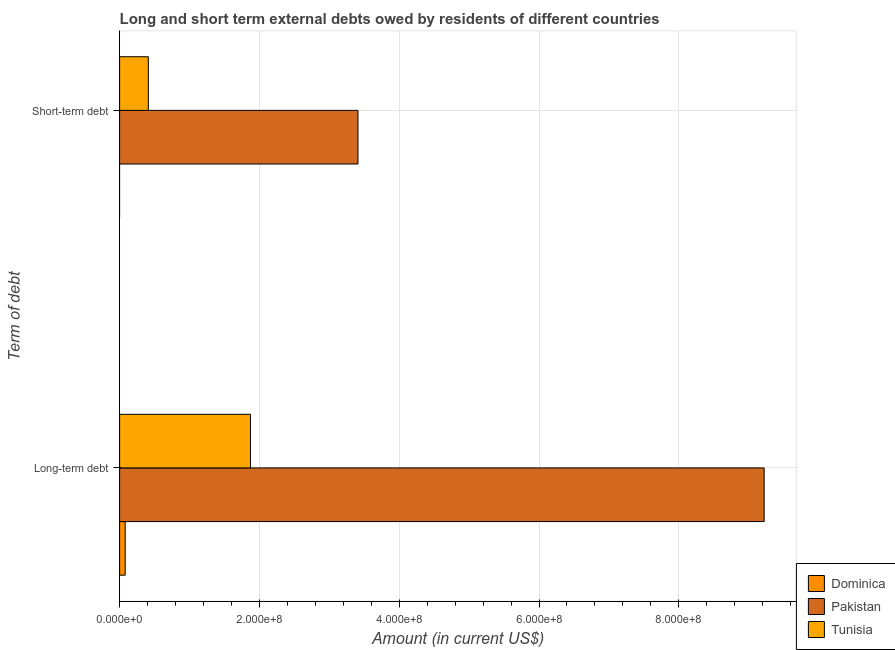How many different coloured bars are there?
Ensure brevity in your answer.  3. How many groups of bars are there?
Your response must be concise. 2. Are the number of bars per tick equal to the number of legend labels?
Your answer should be very brief. No. How many bars are there on the 2nd tick from the top?
Provide a short and direct response. 3. How many bars are there on the 2nd tick from the bottom?
Your answer should be compact. 2. What is the label of the 2nd group of bars from the top?
Keep it short and to the point. Long-term debt. What is the long-term debts owed by residents in Dominica?
Your answer should be compact. 7.98e+06. Across all countries, what is the maximum long-term debts owed by residents?
Ensure brevity in your answer.  9.22e+08. In which country was the short-term debts owed by residents maximum?
Ensure brevity in your answer.  Pakistan. What is the total long-term debts owed by residents in the graph?
Your answer should be very brief. 1.12e+09. What is the difference between the long-term debts owed by residents in Dominica and that in Pakistan?
Give a very brief answer. -9.14e+08. What is the difference between the long-term debts owed by residents in Dominica and the short-term debts owed by residents in Tunisia?
Provide a short and direct response. -3.31e+07. What is the average short-term debts owed by residents per country?
Your answer should be very brief. 1.27e+08. What is the difference between the short-term debts owed by residents and long-term debts owed by residents in Tunisia?
Offer a very short reply. -1.46e+08. In how many countries, is the short-term debts owed by residents greater than 520000000 US$?
Keep it short and to the point. 0. What is the ratio of the long-term debts owed by residents in Pakistan to that in Tunisia?
Give a very brief answer. 4.92. Is the long-term debts owed by residents in Pakistan less than that in Dominica?
Keep it short and to the point. No. In how many countries, is the short-term debts owed by residents greater than the average short-term debts owed by residents taken over all countries?
Ensure brevity in your answer.  1. What is the difference between two consecutive major ticks on the X-axis?
Give a very brief answer. 2.00e+08. Are the values on the major ticks of X-axis written in scientific E-notation?
Your answer should be compact. Yes. Does the graph contain grids?
Keep it short and to the point. Yes. Where does the legend appear in the graph?
Your answer should be compact. Bottom right. How are the legend labels stacked?
Your answer should be compact. Vertical. What is the title of the graph?
Make the answer very short. Long and short term external debts owed by residents of different countries. Does "Channel Islands" appear as one of the legend labels in the graph?
Offer a very short reply. No. What is the label or title of the X-axis?
Make the answer very short. Amount (in current US$). What is the label or title of the Y-axis?
Make the answer very short. Term of debt. What is the Amount (in current US$) in Dominica in Long-term debt?
Keep it short and to the point. 7.98e+06. What is the Amount (in current US$) of Pakistan in Long-term debt?
Give a very brief answer. 9.22e+08. What is the Amount (in current US$) of Tunisia in Long-term debt?
Offer a terse response. 1.87e+08. What is the Amount (in current US$) of Pakistan in Short-term debt?
Ensure brevity in your answer.  3.41e+08. What is the Amount (in current US$) in Tunisia in Short-term debt?
Offer a very short reply. 4.11e+07. Across all Term of debt, what is the maximum Amount (in current US$) of Dominica?
Your answer should be very brief. 7.98e+06. Across all Term of debt, what is the maximum Amount (in current US$) of Pakistan?
Your answer should be compact. 9.22e+08. Across all Term of debt, what is the maximum Amount (in current US$) in Tunisia?
Give a very brief answer. 1.87e+08. Across all Term of debt, what is the minimum Amount (in current US$) in Dominica?
Offer a terse response. 0. Across all Term of debt, what is the minimum Amount (in current US$) in Pakistan?
Your response must be concise. 3.41e+08. Across all Term of debt, what is the minimum Amount (in current US$) in Tunisia?
Your answer should be compact. 4.11e+07. What is the total Amount (in current US$) in Dominica in the graph?
Your answer should be compact. 7.98e+06. What is the total Amount (in current US$) in Pakistan in the graph?
Ensure brevity in your answer.  1.26e+09. What is the total Amount (in current US$) in Tunisia in the graph?
Your response must be concise. 2.28e+08. What is the difference between the Amount (in current US$) in Pakistan in Long-term debt and that in Short-term debt?
Offer a very short reply. 5.81e+08. What is the difference between the Amount (in current US$) in Tunisia in Long-term debt and that in Short-term debt?
Ensure brevity in your answer.  1.46e+08. What is the difference between the Amount (in current US$) in Dominica in Long-term debt and the Amount (in current US$) in Pakistan in Short-term debt?
Provide a short and direct response. -3.33e+08. What is the difference between the Amount (in current US$) in Dominica in Long-term debt and the Amount (in current US$) in Tunisia in Short-term debt?
Keep it short and to the point. -3.31e+07. What is the difference between the Amount (in current US$) in Pakistan in Long-term debt and the Amount (in current US$) in Tunisia in Short-term debt?
Make the answer very short. 8.81e+08. What is the average Amount (in current US$) in Dominica per Term of debt?
Offer a terse response. 3.99e+06. What is the average Amount (in current US$) of Pakistan per Term of debt?
Offer a terse response. 6.32e+08. What is the average Amount (in current US$) in Tunisia per Term of debt?
Give a very brief answer. 1.14e+08. What is the difference between the Amount (in current US$) of Dominica and Amount (in current US$) of Pakistan in Long-term debt?
Offer a terse response. -9.14e+08. What is the difference between the Amount (in current US$) in Dominica and Amount (in current US$) in Tunisia in Long-term debt?
Offer a terse response. -1.79e+08. What is the difference between the Amount (in current US$) in Pakistan and Amount (in current US$) in Tunisia in Long-term debt?
Ensure brevity in your answer.  7.35e+08. What is the difference between the Amount (in current US$) of Pakistan and Amount (in current US$) of Tunisia in Short-term debt?
Give a very brief answer. 3.00e+08. What is the ratio of the Amount (in current US$) in Pakistan in Long-term debt to that in Short-term debt?
Keep it short and to the point. 2.7. What is the ratio of the Amount (in current US$) in Tunisia in Long-term debt to that in Short-term debt?
Give a very brief answer. 4.56. What is the difference between the highest and the second highest Amount (in current US$) of Pakistan?
Provide a short and direct response. 5.81e+08. What is the difference between the highest and the second highest Amount (in current US$) in Tunisia?
Give a very brief answer. 1.46e+08. What is the difference between the highest and the lowest Amount (in current US$) in Dominica?
Provide a short and direct response. 7.98e+06. What is the difference between the highest and the lowest Amount (in current US$) in Pakistan?
Your answer should be very brief. 5.81e+08. What is the difference between the highest and the lowest Amount (in current US$) in Tunisia?
Keep it short and to the point. 1.46e+08. 